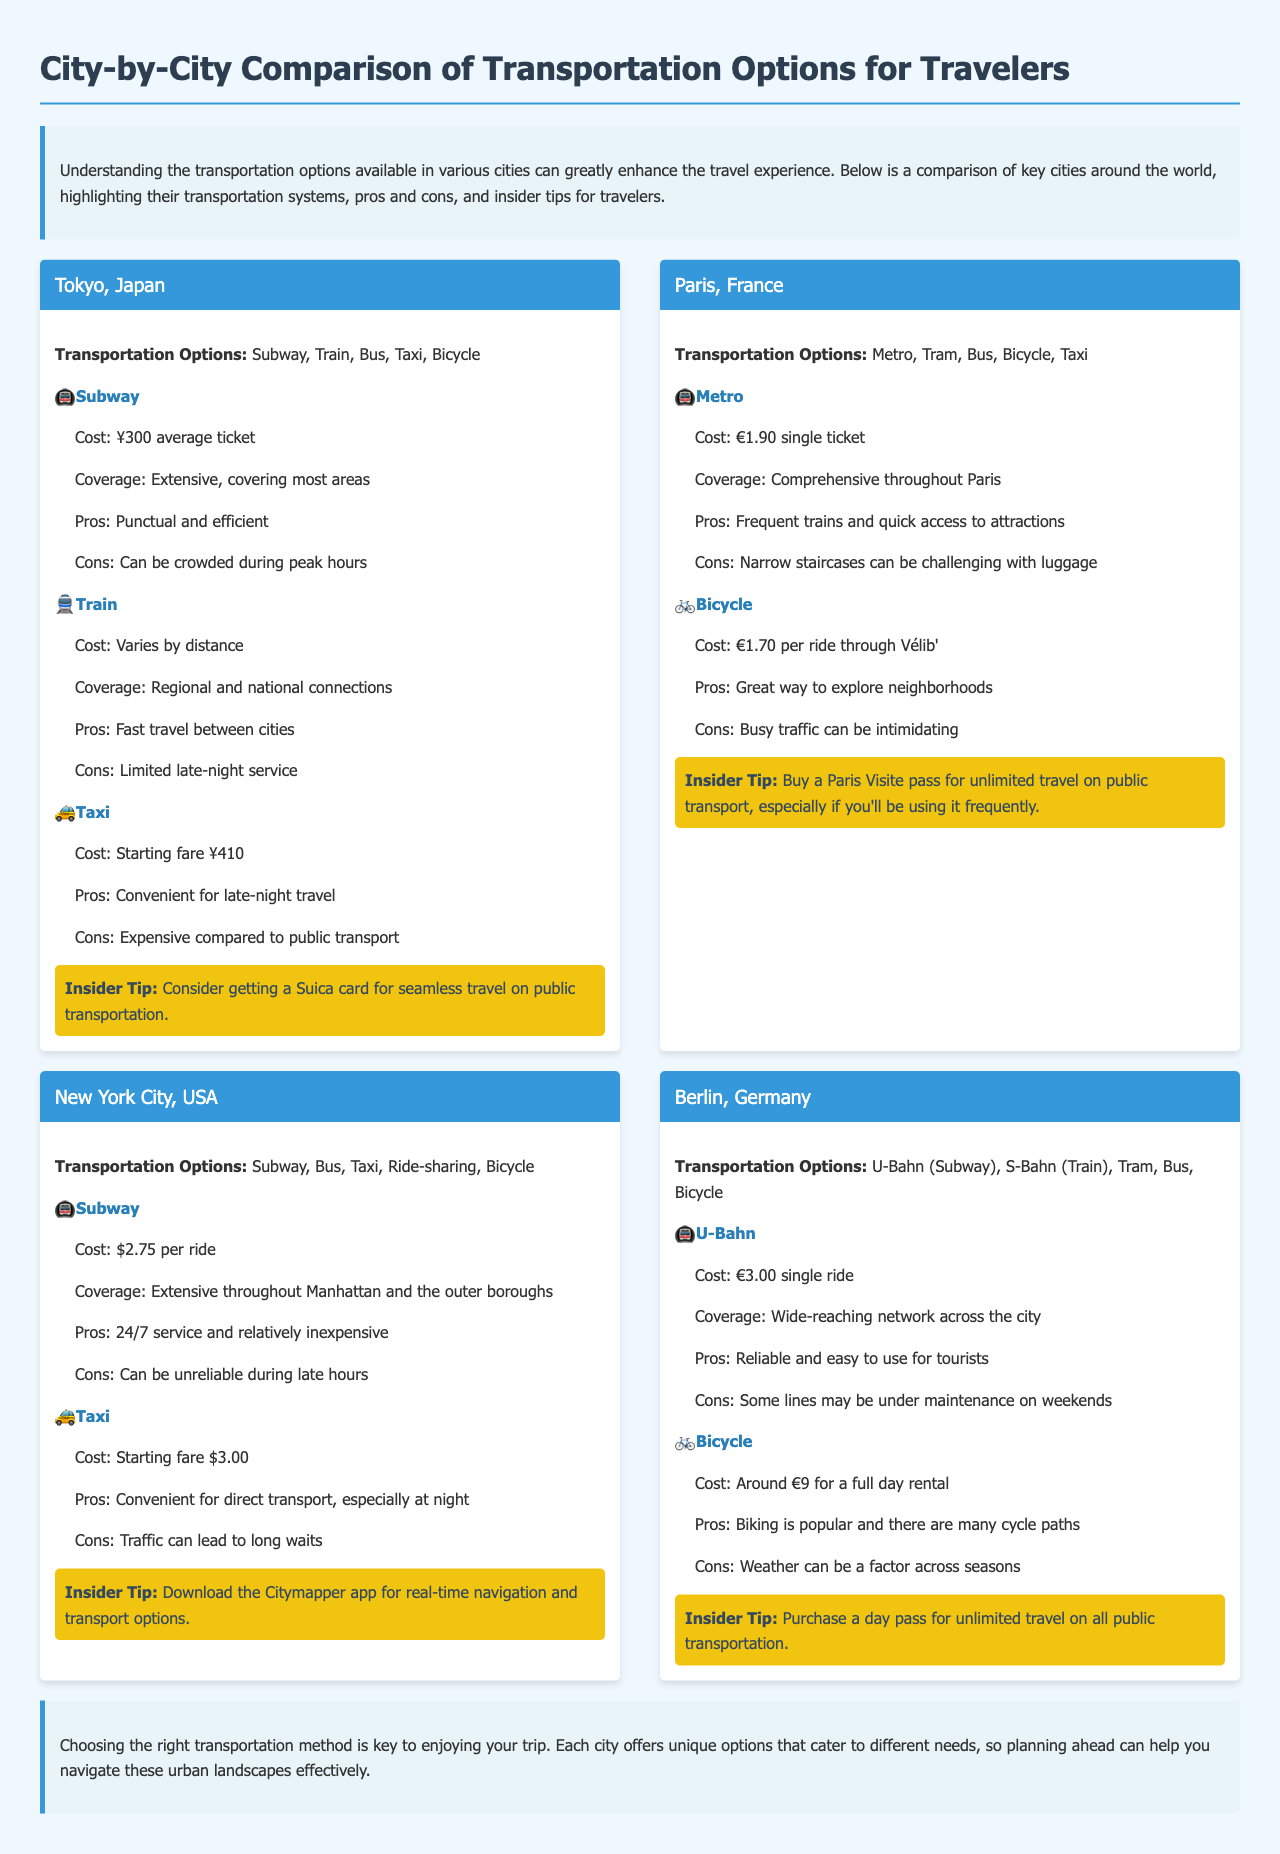What is the average cost of a subway ticket in Tokyo? The average cost of a subway ticket in Tokyo is ¥300.
Answer: ¥300 What transportation options are available in Paris? The transportation options available in Paris are Metro, Tram, Bus, Bicycle, Taxi.
Answer: Metro, Tram, Bus, Bicycle, Taxi What is the pros of using New York City's subway? The pros of using New York City's subway include 24/7 service and relatively inexpensive fares.
Answer: 24/7 service and relatively inexpensive How much does a U-Bahn single ride cost in Berlin? The cost of a U-Bahn single ride in Berlin is €3.00.
Answer: €3.00 Which city offers a day pass for unlimited travel on public transportation? Berlin offers a day pass for unlimited travel on all public transportation.
Answer: Berlin What insider tip is given for using public transportation in Tokyo? The insider tip given for using public transportation in Tokyo is to consider getting a Suica card.
Answer: Consider getting a Suica card What is a potential con of using bicycles in Paris? A potential con of using bicycles in Paris is that busy traffic can be intimidating.
Answer: Busy traffic can be intimidating Which city has a comprehensive metro system that provides quick access to attractions? Paris has a comprehensive metro system that provides quick access to attractions.
Answer: Paris What is the starting fare for a taxi in New York City? The starting fare for a taxi in New York City is $3.00.
Answer: $3.00 